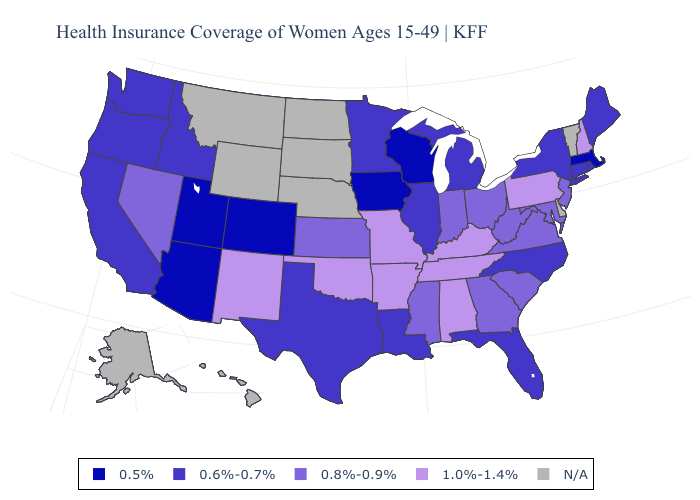Name the states that have a value in the range 0.5%?
Short answer required. Arizona, Colorado, Iowa, Massachusetts, Utah, Wisconsin. Name the states that have a value in the range 1.0%-1.4%?
Give a very brief answer. Alabama, Arkansas, Kentucky, Missouri, New Hampshire, New Mexico, Oklahoma, Pennsylvania, Tennessee. Does Idaho have the highest value in the West?
Give a very brief answer. No. Among the states that border North Carolina , which have the lowest value?
Concise answer only. Georgia, South Carolina, Virginia. Among the states that border South Dakota , which have the lowest value?
Quick response, please. Iowa. Does Louisiana have the lowest value in the South?
Concise answer only. Yes. Name the states that have a value in the range 0.6%-0.7%?
Answer briefly. California, Connecticut, Florida, Idaho, Illinois, Louisiana, Maine, Michigan, Minnesota, New York, North Carolina, Oregon, Rhode Island, Texas, Washington. Does Colorado have the lowest value in the West?
Keep it brief. Yes. What is the value of Nevada?
Keep it brief. 0.8%-0.9%. Which states hav the highest value in the Northeast?
Concise answer only. New Hampshire, Pennsylvania. What is the value of Nebraska?
Give a very brief answer. N/A. Name the states that have a value in the range 0.8%-0.9%?
Quick response, please. Georgia, Indiana, Kansas, Maryland, Mississippi, Nevada, New Jersey, Ohio, South Carolina, Virginia, West Virginia. Name the states that have a value in the range N/A?
Short answer required. Alaska, Delaware, Hawaii, Montana, Nebraska, North Dakota, South Dakota, Vermont, Wyoming. Name the states that have a value in the range 0.6%-0.7%?
Keep it brief. California, Connecticut, Florida, Idaho, Illinois, Louisiana, Maine, Michigan, Minnesota, New York, North Carolina, Oregon, Rhode Island, Texas, Washington. Name the states that have a value in the range 0.8%-0.9%?
Write a very short answer. Georgia, Indiana, Kansas, Maryland, Mississippi, Nevada, New Jersey, Ohio, South Carolina, Virginia, West Virginia. 